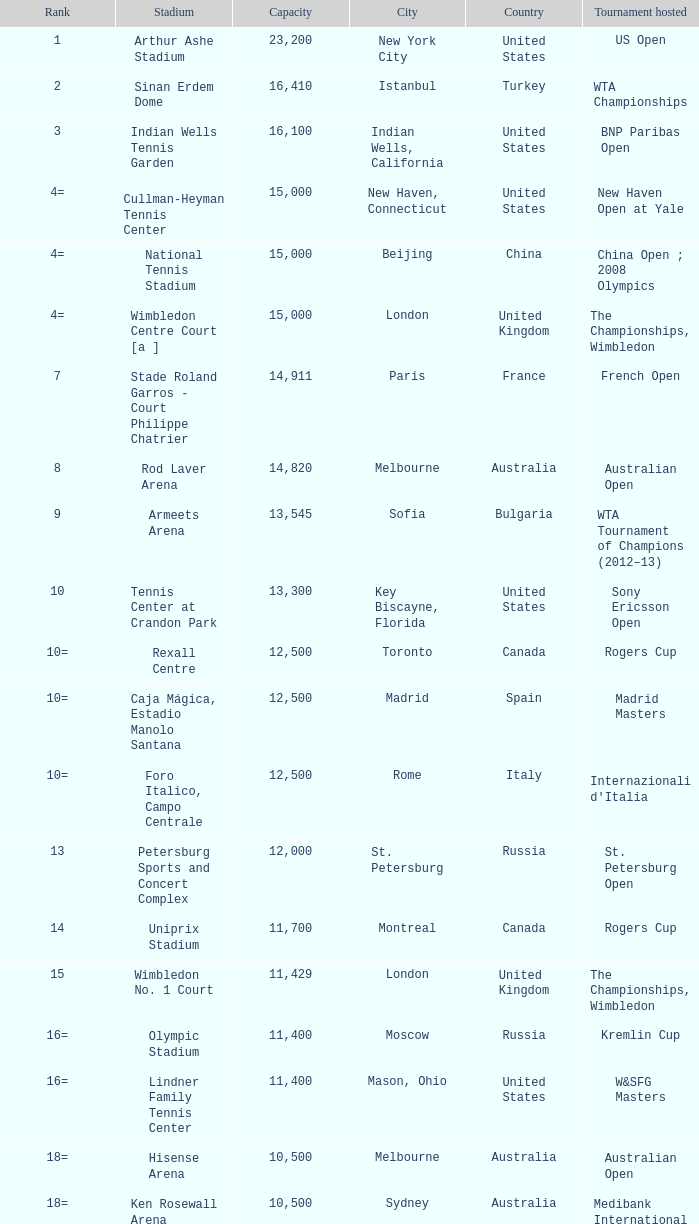What is the mean capacity of rod laver arena as a sports venue? 14820.0. 